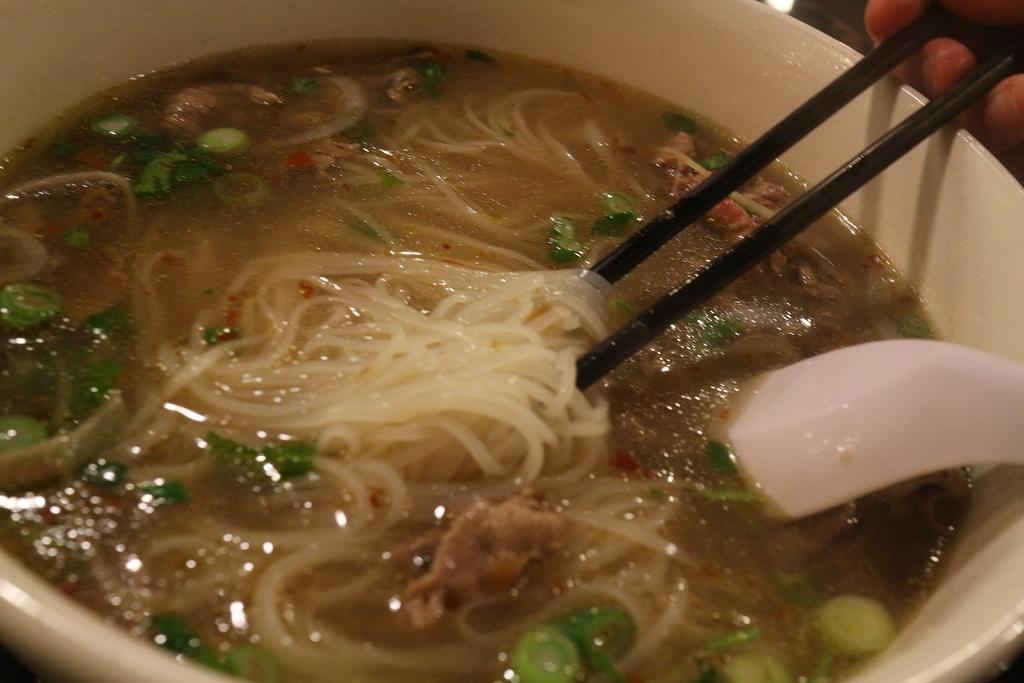What type of food is visible in the image? There are noodles in the image. What other elements can be seen in the image besides the noodles? There are leaves, vegetable pieces, a white color spoon, and a white color bowl visible in the image. What is the color of the spoon and bowl in the image? The spoon and bowl in the image are white in color. What is contained within the bowl? The bowl contains soup. What is the person in the image holding? The person is holding a handler in the image. What is the purpose of the handler in the image? The handler is associated with the bowl. What type of society can be seen in the image? There is no society present in the image; it features a bowl of soup with noodles, leaves, and vegetable pieces. Can you tell me how many notebooks are visible in the image? There are no notebooks present in the image. 